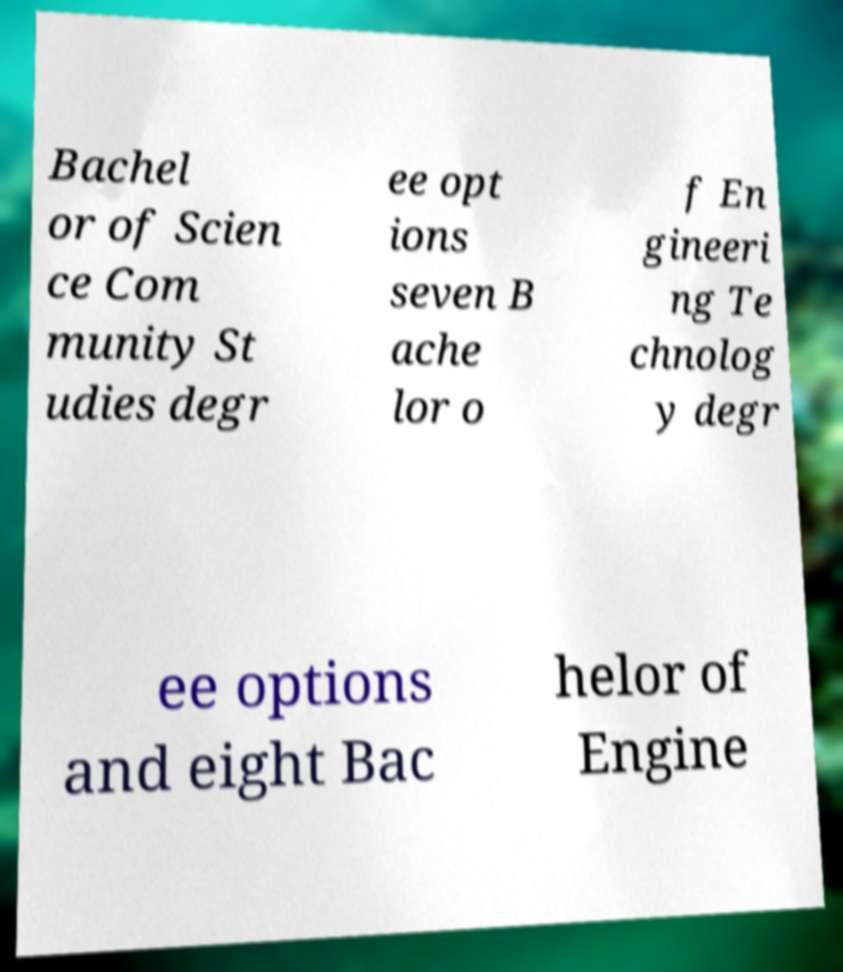Please read and relay the text visible in this image. What does it say? Bachel or of Scien ce Com munity St udies degr ee opt ions seven B ache lor o f En gineeri ng Te chnolog y degr ee options and eight Bac helor of Engine 